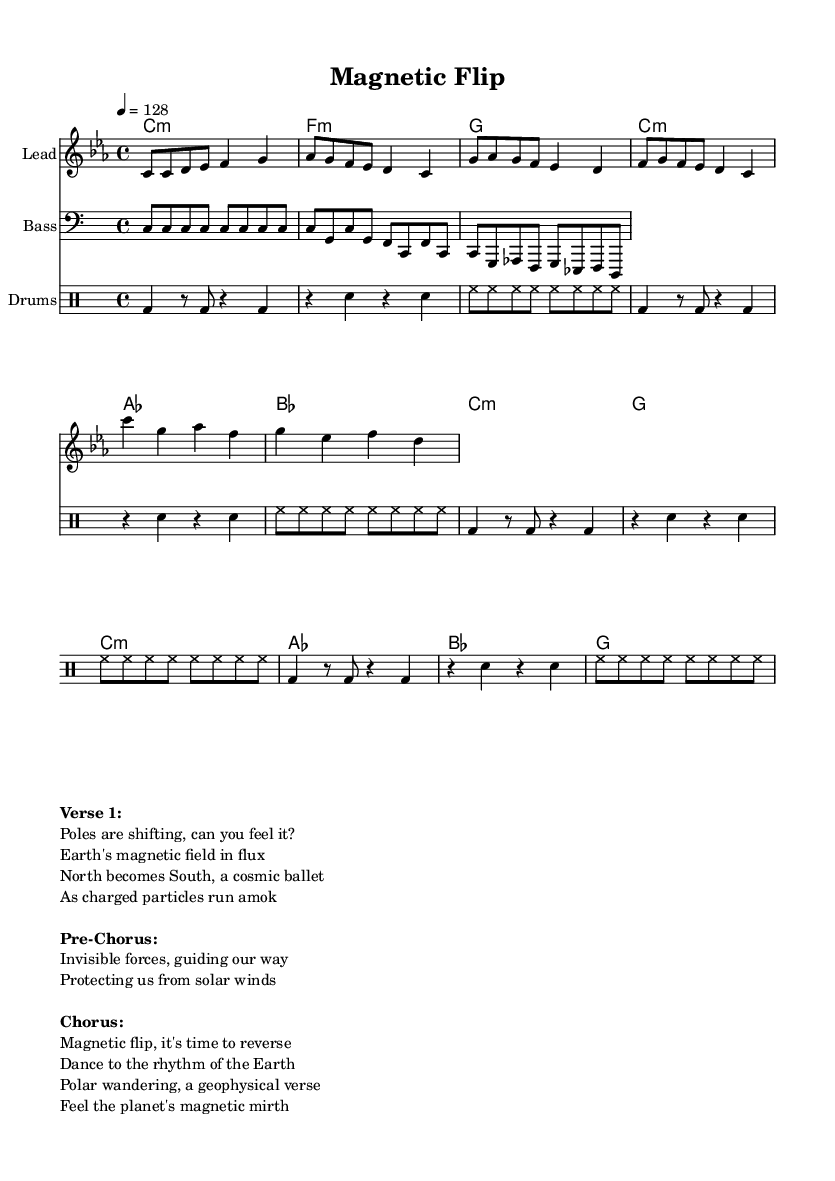What is the key signature of this music? The key signature is indicated at the beginning of the staff, which shows C minor, characterized by three flats (B♭, E♭, and A♭).
Answer: C minor What is the time signature of this music? The time signature is indicated at the beginning of the score and is written as 4/4, which means there are four beats in each measure.
Answer: 4/4 What is the tempo marking of this piece? The tempo marking is found next to the time signature; it shows the speed of the piece as 128 beats per minute.
Answer: 128 How many sections are present in the song structure? The song structure can be analyzed by identifying distinct lyrical sections in the markup. It consists of a Verse, a Pre-Chorus, and a Chorus, totaling three sections.
Answer: 3 What is the primary theme of the lyrics in this electronic track? The lyrics focus on Earth's magnetic field and polar reversals, which can be interpreted as themes central to geophysics and natural phenomena, reflected in the content of the verses and chorus.
Answer: Earth's magnetic field What are the instruments specified in the score? The score lists three different parts: a Lead instrument for the melody, a Bass instrument, and a Drumset for rhythm.
Answer: Lead, Bass, Drums What rhythmic pattern is suggested by the drum section? The drum section features a specific structure with bass drum, snare drum, and hi-hat, where the bass drum is played on the downbeats primarily while the snare provides the backbeat, creating an upbeat electronic dance feel.
Answer: Bass, Snare, Hi-hat 